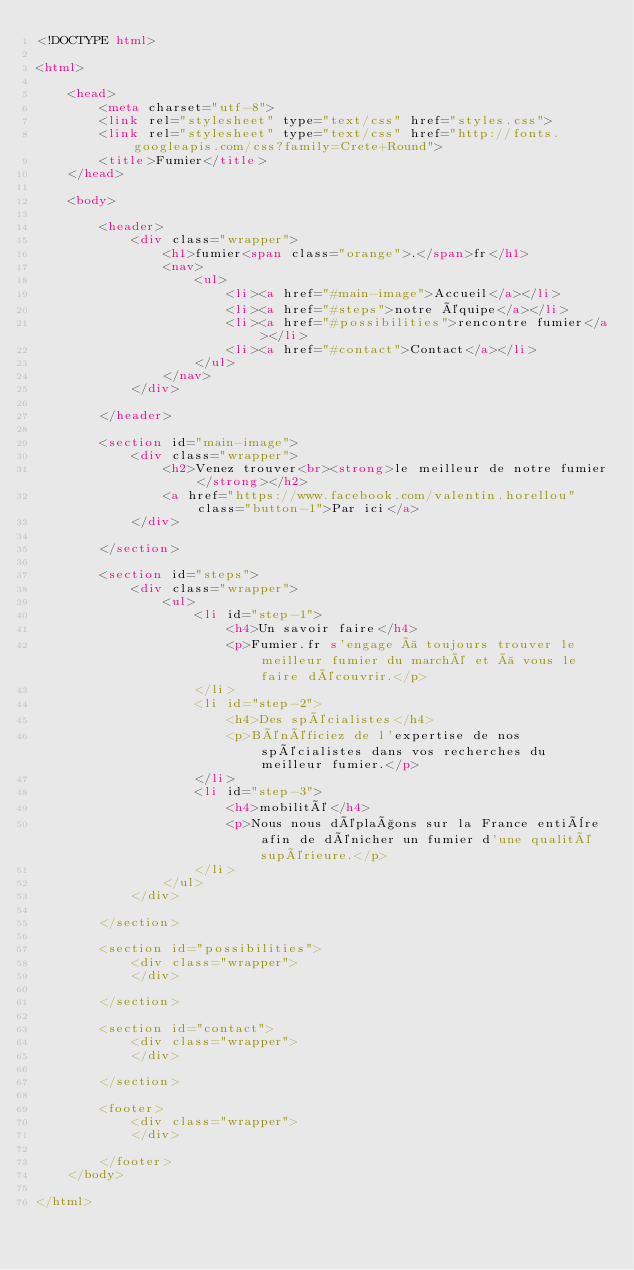Convert code to text. <code><loc_0><loc_0><loc_500><loc_500><_HTML_><!DOCTYPE html>

<html>

	<head>
		<meta charset="utf-8">
		<link rel="stylesheet" type="text/css" href="styles.css">
		<link rel="stylesheet" type="text/css" href="http://fonts.googleapis.com/css?family=Crete+Round">
		<title>Fumier</title>
	</head>

	<body>

		<header>
			<div class="wrapper">
				<h1>fumier<span class="orange">.</span>fr</h1>
				<nav>
					<ul>
						<li><a href="#main-image">Accueil</a></li>
						<li><a href="#steps">notre équipe</a></li>
						<li><a href="#possibilities">rencontre fumier</a></li>
						<li><a href="#contact">Contact</a></li>
					</ul>
				</nav>
			</div>
			
		</header>

		<section id="main-image">
			<div class="wrapper">
				<h2>Venez trouver<br><strong>le meilleur de notre fumier</strong></h2>
				<a href="https://www.facebook.com/valentin.horellou" class="button-1">Par ici</a>
			</div>
			
		</section>

		<section id="steps">
			<div class="wrapper">
				<ul>
					<li id="step-1">
						<h4>Un savoir faire</h4>
						<p>Fumier.fr s'engage à toujours trouver le meilleur fumier du marché et à vous le faire découvrir.</p>
					</li>
					<li id="step-2">
						<h4>Des spécialistes</h4>
						<p>Bénéficiez de l'expertise de nos spécialistes dans vos recherches du meilleur fumier.</p>
					</li>
					<li id="step-3">
						<h4>mobilité</h4>
						<p>Nous nous déplaçons sur la France entière afin de dénicher un fumier d'une qualité supérieure.</p>
					</li>
				</ul>
			</div>
			
		</section>

		<section id="possibilities">
			<div class="wrapper">
			</div>
			
		</section>

		<section id="contact">
			<div class="wrapper">
			</div>
			
		</section>

		<footer>
			<div class="wrapper">
			</div>
			
		</footer>
	</body>

</html>
</code> 